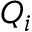<formula> <loc_0><loc_0><loc_500><loc_500>Q _ { i }</formula> 